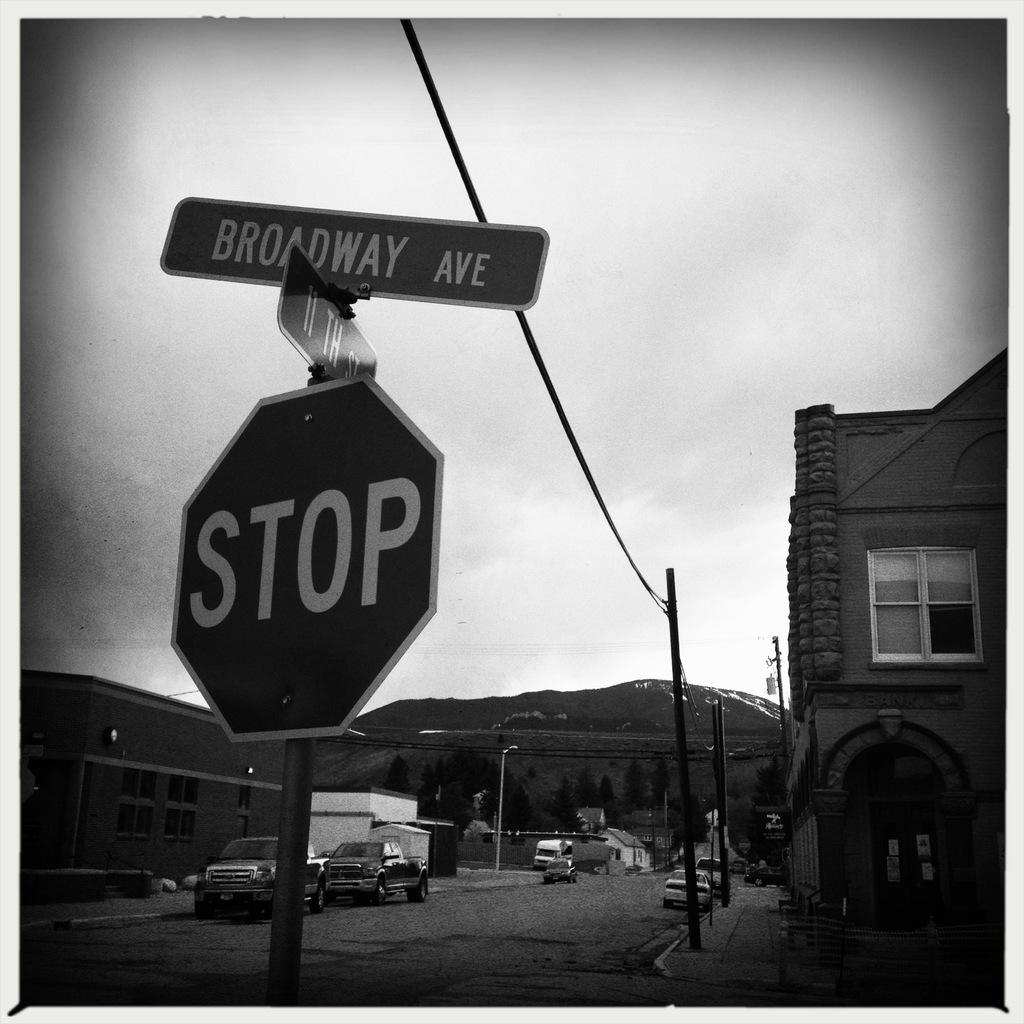<image>
Summarize the visual content of the image. A stop sign has a street sign above it that reads broadway avenue on it. 